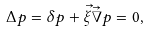<formula> <loc_0><loc_0><loc_500><loc_500>\Delta p = \delta p + \vec { \xi } \vec { \nabla } p = 0 ,</formula> 